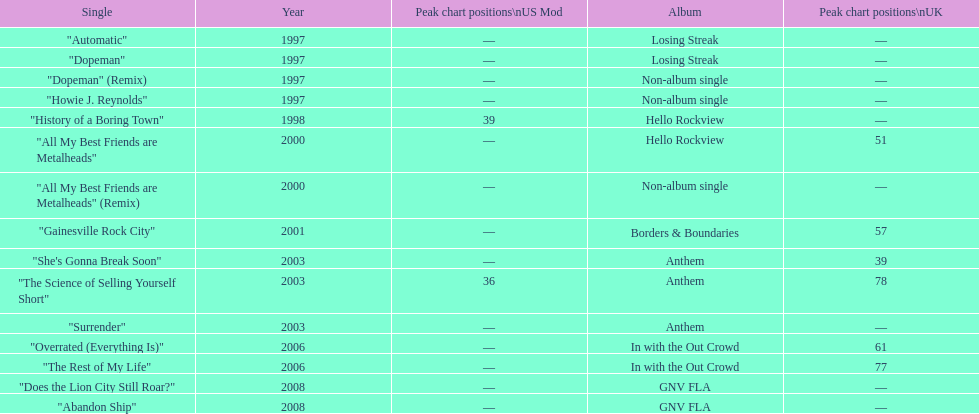What was the earliest single to attain a chart spot? "History of a Boring Town". Parse the full table. {'header': ['Single', 'Year', 'Peak chart positions\\nUS Mod', 'Album', 'Peak chart positions\\nUK'], 'rows': [['"Automatic"', '1997', '—', 'Losing Streak', '—'], ['"Dopeman"', '1997', '—', 'Losing Streak', '—'], ['"Dopeman" (Remix)', '1997', '—', 'Non-album single', '—'], ['"Howie J. Reynolds"', '1997', '—', 'Non-album single', '—'], ['"History of a Boring Town"', '1998', '39', 'Hello Rockview', '—'], ['"All My Best Friends are Metalheads"', '2000', '—', 'Hello Rockview', '51'], ['"All My Best Friends are Metalheads" (Remix)', '2000', '—', 'Non-album single', '—'], ['"Gainesville Rock City"', '2001', '—', 'Borders & Boundaries', '57'], ['"She\'s Gonna Break Soon"', '2003', '—', 'Anthem', '39'], ['"The Science of Selling Yourself Short"', '2003', '36', 'Anthem', '78'], ['"Surrender"', '2003', '—', 'Anthem', '—'], ['"Overrated (Everything Is)"', '2006', '—', 'In with the Out Crowd', '61'], ['"The Rest of My Life"', '2006', '—', 'In with the Out Crowd', '77'], ['"Does the Lion City Still Roar?"', '2008', '—', 'GNV FLA', '—'], ['"Abandon Ship"', '2008', '—', 'GNV FLA', '—']]} 